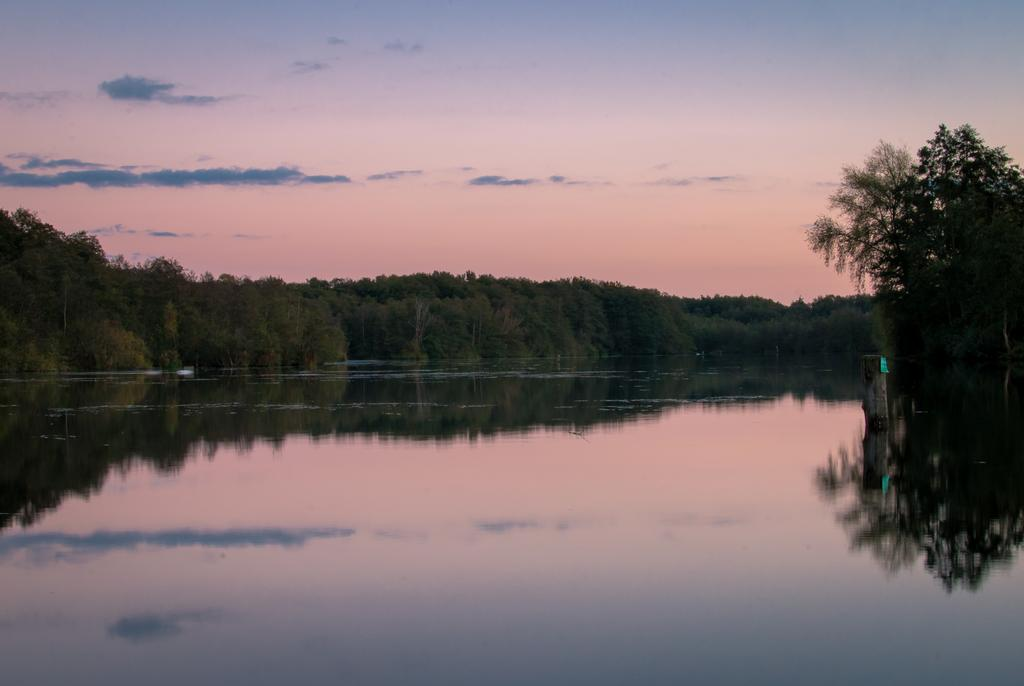What can be seen in the sky in the image? Sky is visible in the image, and clouds are present. What type of vegetation is visible in the image? Trees are visible in the image. What natural element is present in the image? Water is present in the image. What month is depicted in the image? The month is not depicted in the image, as it only shows natural elements like sky, clouds, trees, and water. Can you tell me how many accounts are visible in the image? There are no accounts present in the image; it features natural elements. 